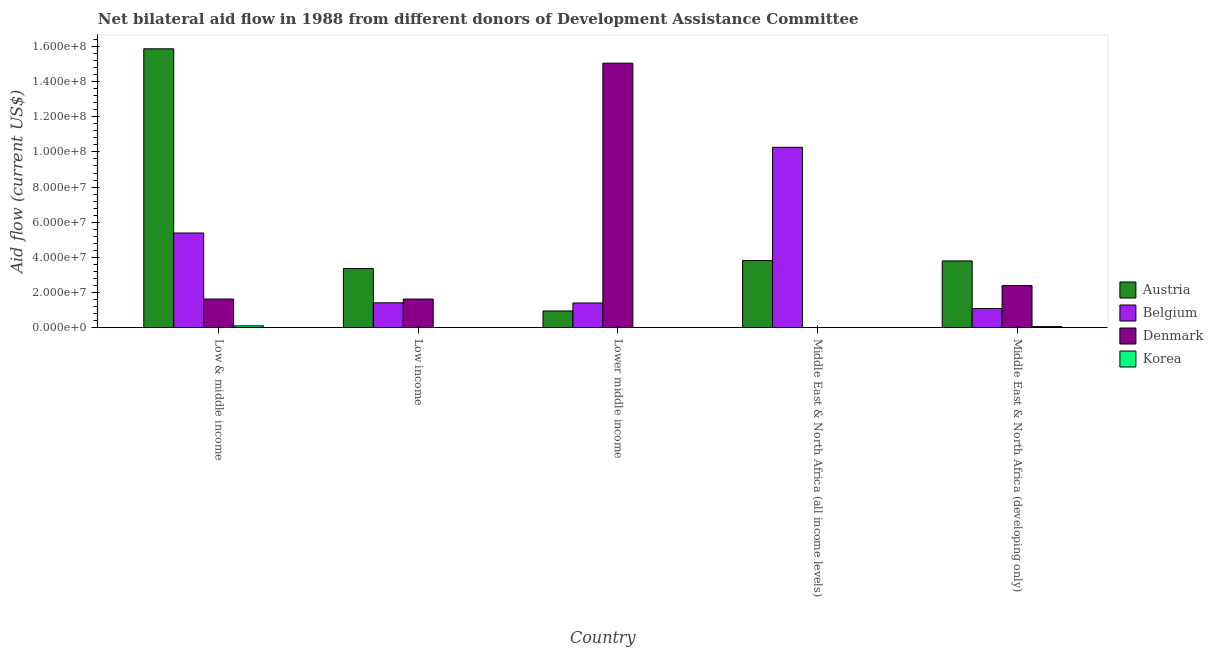Are the number of bars on each tick of the X-axis equal?
Provide a succinct answer. No. What is the label of the 2nd group of bars from the left?
Give a very brief answer. Low income. What is the amount of aid given by denmark in Low & middle income?
Ensure brevity in your answer.  1.63e+07. Across all countries, what is the maximum amount of aid given by korea?
Offer a very short reply. 1.03e+06. Across all countries, what is the minimum amount of aid given by austria?
Your answer should be very brief. 9.50e+06. In which country was the amount of aid given by korea maximum?
Ensure brevity in your answer.  Low & middle income. What is the total amount of aid given by austria in the graph?
Your answer should be compact. 2.78e+08. What is the difference between the amount of aid given by belgium in Low & middle income and that in Middle East & North Africa (all income levels)?
Make the answer very short. -4.88e+07. What is the difference between the amount of aid given by austria in Lower middle income and the amount of aid given by korea in Low & middle income?
Keep it short and to the point. 8.47e+06. What is the average amount of aid given by korea per country?
Make the answer very short. 3.48e+05. What is the difference between the amount of aid given by denmark and amount of aid given by austria in Low income?
Your answer should be compact. -1.74e+07. What is the ratio of the amount of aid given by denmark in Low income to that in Middle East & North Africa (developing only)?
Your answer should be compact. 0.68. What is the difference between the highest and the second highest amount of aid given by denmark?
Provide a short and direct response. 1.27e+08. What is the difference between the highest and the lowest amount of aid given by belgium?
Provide a succinct answer. 9.18e+07. Is the sum of the amount of aid given by korea in Middle East & North Africa (all income levels) and Middle East & North Africa (developing only) greater than the maximum amount of aid given by austria across all countries?
Keep it short and to the point. No. How many countries are there in the graph?
Your response must be concise. 5. Does the graph contain any zero values?
Your answer should be compact. Yes. Does the graph contain grids?
Your answer should be very brief. No. Where does the legend appear in the graph?
Keep it short and to the point. Center right. How many legend labels are there?
Give a very brief answer. 4. What is the title of the graph?
Your answer should be very brief. Net bilateral aid flow in 1988 from different donors of Development Assistance Committee. Does "Portugal" appear as one of the legend labels in the graph?
Keep it short and to the point. No. What is the label or title of the X-axis?
Your response must be concise. Country. What is the label or title of the Y-axis?
Provide a short and direct response. Aid flow (current US$). What is the Aid flow (current US$) of Austria in Low & middle income?
Provide a short and direct response. 1.59e+08. What is the Aid flow (current US$) of Belgium in Low & middle income?
Ensure brevity in your answer.  5.39e+07. What is the Aid flow (current US$) in Denmark in Low & middle income?
Provide a short and direct response. 1.63e+07. What is the Aid flow (current US$) of Korea in Low & middle income?
Make the answer very short. 1.03e+06. What is the Aid flow (current US$) of Austria in Low income?
Provide a short and direct response. 3.36e+07. What is the Aid flow (current US$) of Belgium in Low income?
Give a very brief answer. 1.41e+07. What is the Aid flow (current US$) in Denmark in Low income?
Offer a terse response. 1.63e+07. What is the Aid flow (current US$) in Korea in Low income?
Give a very brief answer. 3.00e+04. What is the Aid flow (current US$) in Austria in Lower middle income?
Ensure brevity in your answer.  9.50e+06. What is the Aid flow (current US$) of Belgium in Lower middle income?
Offer a very short reply. 1.40e+07. What is the Aid flow (current US$) in Denmark in Lower middle income?
Your answer should be very brief. 1.50e+08. What is the Aid flow (current US$) in Korea in Lower middle income?
Provide a succinct answer. 3.00e+04. What is the Aid flow (current US$) of Austria in Middle East & North Africa (all income levels)?
Keep it short and to the point. 3.82e+07. What is the Aid flow (current US$) of Belgium in Middle East & North Africa (all income levels)?
Give a very brief answer. 1.03e+08. What is the Aid flow (current US$) in Austria in Middle East & North Africa (developing only)?
Your answer should be very brief. 3.80e+07. What is the Aid flow (current US$) in Belgium in Middle East & North Africa (developing only)?
Keep it short and to the point. 1.09e+07. What is the Aid flow (current US$) in Denmark in Middle East & North Africa (developing only)?
Provide a short and direct response. 2.40e+07. What is the Aid flow (current US$) of Korea in Middle East & North Africa (developing only)?
Ensure brevity in your answer.  6.20e+05. Across all countries, what is the maximum Aid flow (current US$) in Austria?
Offer a terse response. 1.59e+08. Across all countries, what is the maximum Aid flow (current US$) of Belgium?
Your answer should be very brief. 1.03e+08. Across all countries, what is the maximum Aid flow (current US$) in Denmark?
Your response must be concise. 1.50e+08. Across all countries, what is the maximum Aid flow (current US$) in Korea?
Your answer should be compact. 1.03e+06. Across all countries, what is the minimum Aid flow (current US$) in Austria?
Provide a short and direct response. 9.50e+06. Across all countries, what is the minimum Aid flow (current US$) of Belgium?
Make the answer very short. 1.09e+07. Across all countries, what is the minimum Aid flow (current US$) of Denmark?
Provide a short and direct response. 0. What is the total Aid flow (current US$) of Austria in the graph?
Offer a terse response. 2.78e+08. What is the total Aid flow (current US$) in Belgium in the graph?
Ensure brevity in your answer.  1.96e+08. What is the total Aid flow (current US$) of Denmark in the graph?
Offer a very short reply. 2.07e+08. What is the total Aid flow (current US$) of Korea in the graph?
Ensure brevity in your answer.  1.74e+06. What is the difference between the Aid flow (current US$) of Austria in Low & middle income and that in Low income?
Offer a very short reply. 1.25e+08. What is the difference between the Aid flow (current US$) in Belgium in Low & middle income and that in Low income?
Your answer should be compact. 3.97e+07. What is the difference between the Aid flow (current US$) of Korea in Low & middle income and that in Low income?
Provide a short and direct response. 1.00e+06. What is the difference between the Aid flow (current US$) in Austria in Low & middle income and that in Lower middle income?
Your answer should be very brief. 1.49e+08. What is the difference between the Aid flow (current US$) of Belgium in Low & middle income and that in Lower middle income?
Provide a succinct answer. 3.98e+07. What is the difference between the Aid flow (current US$) in Denmark in Low & middle income and that in Lower middle income?
Make the answer very short. -1.34e+08. What is the difference between the Aid flow (current US$) in Korea in Low & middle income and that in Lower middle income?
Ensure brevity in your answer.  1.00e+06. What is the difference between the Aid flow (current US$) of Austria in Low & middle income and that in Middle East & North Africa (all income levels)?
Your response must be concise. 1.20e+08. What is the difference between the Aid flow (current US$) of Belgium in Low & middle income and that in Middle East & North Africa (all income levels)?
Keep it short and to the point. -4.88e+07. What is the difference between the Aid flow (current US$) in Korea in Low & middle income and that in Middle East & North Africa (all income levels)?
Offer a terse response. 1.00e+06. What is the difference between the Aid flow (current US$) of Austria in Low & middle income and that in Middle East & North Africa (developing only)?
Provide a succinct answer. 1.21e+08. What is the difference between the Aid flow (current US$) of Belgium in Low & middle income and that in Middle East & North Africa (developing only)?
Ensure brevity in your answer.  4.30e+07. What is the difference between the Aid flow (current US$) in Denmark in Low & middle income and that in Middle East & North Africa (developing only)?
Ensure brevity in your answer.  -7.68e+06. What is the difference between the Aid flow (current US$) in Korea in Low & middle income and that in Middle East & North Africa (developing only)?
Your answer should be compact. 4.10e+05. What is the difference between the Aid flow (current US$) of Austria in Low income and that in Lower middle income?
Offer a terse response. 2.41e+07. What is the difference between the Aid flow (current US$) of Denmark in Low income and that in Lower middle income?
Make the answer very short. -1.34e+08. What is the difference between the Aid flow (current US$) in Austria in Low income and that in Middle East & North Africa (all income levels)?
Offer a terse response. -4.56e+06. What is the difference between the Aid flow (current US$) of Belgium in Low income and that in Middle East & North Africa (all income levels)?
Your response must be concise. -8.85e+07. What is the difference between the Aid flow (current US$) of Korea in Low income and that in Middle East & North Africa (all income levels)?
Keep it short and to the point. 0. What is the difference between the Aid flow (current US$) of Austria in Low income and that in Middle East & North Africa (developing only)?
Provide a succinct answer. -4.34e+06. What is the difference between the Aid flow (current US$) in Belgium in Low income and that in Middle East & North Africa (developing only)?
Your answer should be very brief. 3.28e+06. What is the difference between the Aid flow (current US$) in Denmark in Low income and that in Middle East & North Africa (developing only)?
Your answer should be very brief. -7.70e+06. What is the difference between the Aid flow (current US$) of Korea in Low income and that in Middle East & North Africa (developing only)?
Your answer should be very brief. -5.90e+05. What is the difference between the Aid flow (current US$) of Austria in Lower middle income and that in Middle East & North Africa (all income levels)?
Make the answer very short. -2.87e+07. What is the difference between the Aid flow (current US$) of Belgium in Lower middle income and that in Middle East & North Africa (all income levels)?
Give a very brief answer. -8.86e+07. What is the difference between the Aid flow (current US$) in Austria in Lower middle income and that in Middle East & North Africa (developing only)?
Offer a terse response. -2.85e+07. What is the difference between the Aid flow (current US$) in Belgium in Lower middle income and that in Middle East & North Africa (developing only)?
Make the answer very short. 3.18e+06. What is the difference between the Aid flow (current US$) of Denmark in Lower middle income and that in Middle East & North Africa (developing only)?
Your response must be concise. 1.27e+08. What is the difference between the Aid flow (current US$) of Korea in Lower middle income and that in Middle East & North Africa (developing only)?
Ensure brevity in your answer.  -5.90e+05. What is the difference between the Aid flow (current US$) of Austria in Middle East & North Africa (all income levels) and that in Middle East & North Africa (developing only)?
Offer a terse response. 2.20e+05. What is the difference between the Aid flow (current US$) of Belgium in Middle East & North Africa (all income levels) and that in Middle East & North Africa (developing only)?
Keep it short and to the point. 9.18e+07. What is the difference between the Aid flow (current US$) of Korea in Middle East & North Africa (all income levels) and that in Middle East & North Africa (developing only)?
Your answer should be compact. -5.90e+05. What is the difference between the Aid flow (current US$) of Austria in Low & middle income and the Aid flow (current US$) of Belgium in Low income?
Your response must be concise. 1.45e+08. What is the difference between the Aid flow (current US$) in Austria in Low & middle income and the Aid flow (current US$) in Denmark in Low income?
Provide a short and direct response. 1.42e+08. What is the difference between the Aid flow (current US$) in Austria in Low & middle income and the Aid flow (current US$) in Korea in Low income?
Keep it short and to the point. 1.59e+08. What is the difference between the Aid flow (current US$) of Belgium in Low & middle income and the Aid flow (current US$) of Denmark in Low income?
Your answer should be compact. 3.76e+07. What is the difference between the Aid flow (current US$) of Belgium in Low & middle income and the Aid flow (current US$) of Korea in Low income?
Offer a terse response. 5.38e+07. What is the difference between the Aid flow (current US$) of Denmark in Low & middle income and the Aid flow (current US$) of Korea in Low income?
Keep it short and to the point. 1.63e+07. What is the difference between the Aid flow (current US$) in Austria in Low & middle income and the Aid flow (current US$) in Belgium in Lower middle income?
Offer a terse response. 1.45e+08. What is the difference between the Aid flow (current US$) of Austria in Low & middle income and the Aid flow (current US$) of Denmark in Lower middle income?
Offer a very short reply. 8.18e+06. What is the difference between the Aid flow (current US$) of Austria in Low & middle income and the Aid flow (current US$) of Korea in Lower middle income?
Provide a short and direct response. 1.59e+08. What is the difference between the Aid flow (current US$) in Belgium in Low & middle income and the Aid flow (current US$) in Denmark in Lower middle income?
Your answer should be compact. -9.66e+07. What is the difference between the Aid flow (current US$) in Belgium in Low & middle income and the Aid flow (current US$) in Korea in Lower middle income?
Your answer should be very brief. 5.38e+07. What is the difference between the Aid flow (current US$) in Denmark in Low & middle income and the Aid flow (current US$) in Korea in Lower middle income?
Give a very brief answer. 1.63e+07. What is the difference between the Aid flow (current US$) in Austria in Low & middle income and the Aid flow (current US$) in Belgium in Middle East & North Africa (all income levels)?
Ensure brevity in your answer.  5.60e+07. What is the difference between the Aid flow (current US$) in Austria in Low & middle income and the Aid flow (current US$) in Korea in Middle East & North Africa (all income levels)?
Provide a short and direct response. 1.59e+08. What is the difference between the Aid flow (current US$) in Belgium in Low & middle income and the Aid flow (current US$) in Korea in Middle East & North Africa (all income levels)?
Keep it short and to the point. 5.38e+07. What is the difference between the Aid flow (current US$) of Denmark in Low & middle income and the Aid flow (current US$) of Korea in Middle East & North Africa (all income levels)?
Your response must be concise. 1.63e+07. What is the difference between the Aid flow (current US$) in Austria in Low & middle income and the Aid flow (current US$) in Belgium in Middle East & North Africa (developing only)?
Your answer should be compact. 1.48e+08. What is the difference between the Aid flow (current US$) of Austria in Low & middle income and the Aid flow (current US$) of Denmark in Middle East & North Africa (developing only)?
Offer a very short reply. 1.35e+08. What is the difference between the Aid flow (current US$) in Austria in Low & middle income and the Aid flow (current US$) in Korea in Middle East & North Africa (developing only)?
Ensure brevity in your answer.  1.58e+08. What is the difference between the Aid flow (current US$) in Belgium in Low & middle income and the Aid flow (current US$) in Denmark in Middle East & North Africa (developing only)?
Your response must be concise. 2.99e+07. What is the difference between the Aid flow (current US$) of Belgium in Low & middle income and the Aid flow (current US$) of Korea in Middle East & North Africa (developing only)?
Keep it short and to the point. 5.32e+07. What is the difference between the Aid flow (current US$) of Denmark in Low & middle income and the Aid flow (current US$) of Korea in Middle East & North Africa (developing only)?
Make the answer very short. 1.57e+07. What is the difference between the Aid flow (current US$) in Austria in Low income and the Aid flow (current US$) in Belgium in Lower middle income?
Your response must be concise. 1.96e+07. What is the difference between the Aid flow (current US$) in Austria in Low income and the Aid flow (current US$) in Denmark in Lower middle income?
Offer a very short reply. -1.17e+08. What is the difference between the Aid flow (current US$) in Austria in Low income and the Aid flow (current US$) in Korea in Lower middle income?
Provide a succinct answer. 3.36e+07. What is the difference between the Aid flow (current US$) in Belgium in Low income and the Aid flow (current US$) in Denmark in Lower middle income?
Your response must be concise. -1.36e+08. What is the difference between the Aid flow (current US$) of Belgium in Low income and the Aid flow (current US$) of Korea in Lower middle income?
Offer a terse response. 1.41e+07. What is the difference between the Aid flow (current US$) in Denmark in Low income and the Aid flow (current US$) in Korea in Lower middle income?
Ensure brevity in your answer.  1.62e+07. What is the difference between the Aid flow (current US$) of Austria in Low income and the Aid flow (current US$) of Belgium in Middle East & North Africa (all income levels)?
Provide a succinct answer. -6.90e+07. What is the difference between the Aid flow (current US$) in Austria in Low income and the Aid flow (current US$) in Korea in Middle East & North Africa (all income levels)?
Your response must be concise. 3.36e+07. What is the difference between the Aid flow (current US$) in Belgium in Low income and the Aid flow (current US$) in Korea in Middle East & North Africa (all income levels)?
Provide a short and direct response. 1.41e+07. What is the difference between the Aid flow (current US$) in Denmark in Low income and the Aid flow (current US$) in Korea in Middle East & North Africa (all income levels)?
Your answer should be very brief. 1.62e+07. What is the difference between the Aid flow (current US$) in Austria in Low income and the Aid flow (current US$) in Belgium in Middle East & North Africa (developing only)?
Your answer should be very brief. 2.28e+07. What is the difference between the Aid flow (current US$) of Austria in Low income and the Aid flow (current US$) of Denmark in Middle East & North Africa (developing only)?
Provide a succinct answer. 9.66e+06. What is the difference between the Aid flow (current US$) of Austria in Low income and the Aid flow (current US$) of Korea in Middle East & North Africa (developing only)?
Provide a short and direct response. 3.30e+07. What is the difference between the Aid flow (current US$) of Belgium in Low income and the Aid flow (current US$) of Denmark in Middle East & North Africa (developing only)?
Your response must be concise. -9.83e+06. What is the difference between the Aid flow (current US$) of Belgium in Low income and the Aid flow (current US$) of Korea in Middle East & North Africa (developing only)?
Give a very brief answer. 1.35e+07. What is the difference between the Aid flow (current US$) in Denmark in Low income and the Aid flow (current US$) in Korea in Middle East & North Africa (developing only)?
Provide a succinct answer. 1.56e+07. What is the difference between the Aid flow (current US$) of Austria in Lower middle income and the Aid flow (current US$) of Belgium in Middle East & North Africa (all income levels)?
Your answer should be compact. -9.32e+07. What is the difference between the Aid flow (current US$) of Austria in Lower middle income and the Aid flow (current US$) of Korea in Middle East & North Africa (all income levels)?
Offer a terse response. 9.47e+06. What is the difference between the Aid flow (current US$) in Belgium in Lower middle income and the Aid flow (current US$) in Korea in Middle East & North Africa (all income levels)?
Your answer should be very brief. 1.40e+07. What is the difference between the Aid flow (current US$) in Denmark in Lower middle income and the Aid flow (current US$) in Korea in Middle East & North Africa (all income levels)?
Give a very brief answer. 1.50e+08. What is the difference between the Aid flow (current US$) of Austria in Lower middle income and the Aid flow (current US$) of Belgium in Middle East & North Africa (developing only)?
Provide a short and direct response. -1.36e+06. What is the difference between the Aid flow (current US$) in Austria in Lower middle income and the Aid flow (current US$) in Denmark in Middle East & North Africa (developing only)?
Make the answer very short. -1.45e+07. What is the difference between the Aid flow (current US$) of Austria in Lower middle income and the Aid flow (current US$) of Korea in Middle East & North Africa (developing only)?
Provide a succinct answer. 8.88e+06. What is the difference between the Aid flow (current US$) in Belgium in Lower middle income and the Aid flow (current US$) in Denmark in Middle East & North Africa (developing only)?
Your response must be concise. -9.93e+06. What is the difference between the Aid flow (current US$) in Belgium in Lower middle income and the Aid flow (current US$) in Korea in Middle East & North Africa (developing only)?
Offer a very short reply. 1.34e+07. What is the difference between the Aid flow (current US$) of Denmark in Lower middle income and the Aid flow (current US$) of Korea in Middle East & North Africa (developing only)?
Give a very brief answer. 1.50e+08. What is the difference between the Aid flow (current US$) in Austria in Middle East & North Africa (all income levels) and the Aid flow (current US$) in Belgium in Middle East & North Africa (developing only)?
Make the answer very short. 2.73e+07. What is the difference between the Aid flow (current US$) of Austria in Middle East & North Africa (all income levels) and the Aid flow (current US$) of Denmark in Middle East & North Africa (developing only)?
Make the answer very short. 1.42e+07. What is the difference between the Aid flow (current US$) of Austria in Middle East & North Africa (all income levels) and the Aid flow (current US$) of Korea in Middle East & North Africa (developing only)?
Your response must be concise. 3.76e+07. What is the difference between the Aid flow (current US$) in Belgium in Middle East & North Africa (all income levels) and the Aid flow (current US$) in Denmark in Middle East & North Africa (developing only)?
Offer a terse response. 7.87e+07. What is the difference between the Aid flow (current US$) of Belgium in Middle East & North Africa (all income levels) and the Aid flow (current US$) of Korea in Middle East & North Africa (developing only)?
Provide a short and direct response. 1.02e+08. What is the average Aid flow (current US$) in Austria per country?
Your answer should be compact. 5.56e+07. What is the average Aid flow (current US$) in Belgium per country?
Ensure brevity in your answer.  3.91e+07. What is the average Aid flow (current US$) in Denmark per country?
Keep it short and to the point. 4.14e+07. What is the average Aid flow (current US$) of Korea per country?
Your answer should be very brief. 3.48e+05. What is the difference between the Aid flow (current US$) of Austria and Aid flow (current US$) of Belgium in Low & middle income?
Make the answer very short. 1.05e+08. What is the difference between the Aid flow (current US$) of Austria and Aid flow (current US$) of Denmark in Low & middle income?
Offer a terse response. 1.42e+08. What is the difference between the Aid flow (current US$) in Austria and Aid flow (current US$) in Korea in Low & middle income?
Give a very brief answer. 1.58e+08. What is the difference between the Aid flow (current US$) of Belgium and Aid flow (current US$) of Denmark in Low & middle income?
Your response must be concise. 3.76e+07. What is the difference between the Aid flow (current US$) of Belgium and Aid flow (current US$) of Korea in Low & middle income?
Keep it short and to the point. 5.28e+07. What is the difference between the Aid flow (current US$) of Denmark and Aid flow (current US$) of Korea in Low & middle income?
Ensure brevity in your answer.  1.53e+07. What is the difference between the Aid flow (current US$) in Austria and Aid flow (current US$) in Belgium in Low income?
Offer a very short reply. 1.95e+07. What is the difference between the Aid flow (current US$) of Austria and Aid flow (current US$) of Denmark in Low income?
Your response must be concise. 1.74e+07. What is the difference between the Aid flow (current US$) in Austria and Aid flow (current US$) in Korea in Low income?
Offer a very short reply. 3.36e+07. What is the difference between the Aid flow (current US$) of Belgium and Aid flow (current US$) of Denmark in Low income?
Provide a succinct answer. -2.13e+06. What is the difference between the Aid flow (current US$) in Belgium and Aid flow (current US$) in Korea in Low income?
Your answer should be very brief. 1.41e+07. What is the difference between the Aid flow (current US$) in Denmark and Aid flow (current US$) in Korea in Low income?
Provide a succinct answer. 1.62e+07. What is the difference between the Aid flow (current US$) of Austria and Aid flow (current US$) of Belgium in Lower middle income?
Keep it short and to the point. -4.54e+06. What is the difference between the Aid flow (current US$) of Austria and Aid flow (current US$) of Denmark in Lower middle income?
Your answer should be compact. -1.41e+08. What is the difference between the Aid flow (current US$) in Austria and Aid flow (current US$) in Korea in Lower middle income?
Provide a short and direct response. 9.47e+06. What is the difference between the Aid flow (current US$) in Belgium and Aid flow (current US$) in Denmark in Lower middle income?
Give a very brief answer. -1.36e+08. What is the difference between the Aid flow (current US$) in Belgium and Aid flow (current US$) in Korea in Lower middle income?
Your answer should be compact. 1.40e+07. What is the difference between the Aid flow (current US$) of Denmark and Aid flow (current US$) of Korea in Lower middle income?
Keep it short and to the point. 1.50e+08. What is the difference between the Aid flow (current US$) of Austria and Aid flow (current US$) of Belgium in Middle East & North Africa (all income levels)?
Provide a succinct answer. -6.45e+07. What is the difference between the Aid flow (current US$) in Austria and Aid flow (current US$) in Korea in Middle East & North Africa (all income levels)?
Provide a succinct answer. 3.82e+07. What is the difference between the Aid flow (current US$) in Belgium and Aid flow (current US$) in Korea in Middle East & North Africa (all income levels)?
Your response must be concise. 1.03e+08. What is the difference between the Aid flow (current US$) in Austria and Aid flow (current US$) in Belgium in Middle East & North Africa (developing only)?
Your answer should be very brief. 2.71e+07. What is the difference between the Aid flow (current US$) in Austria and Aid flow (current US$) in Denmark in Middle East & North Africa (developing only)?
Make the answer very short. 1.40e+07. What is the difference between the Aid flow (current US$) of Austria and Aid flow (current US$) of Korea in Middle East & North Africa (developing only)?
Provide a short and direct response. 3.74e+07. What is the difference between the Aid flow (current US$) in Belgium and Aid flow (current US$) in Denmark in Middle East & North Africa (developing only)?
Keep it short and to the point. -1.31e+07. What is the difference between the Aid flow (current US$) of Belgium and Aid flow (current US$) of Korea in Middle East & North Africa (developing only)?
Your response must be concise. 1.02e+07. What is the difference between the Aid flow (current US$) of Denmark and Aid flow (current US$) of Korea in Middle East & North Africa (developing only)?
Your answer should be very brief. 2.34e+07. What is the ratio of the Aid flow (current US$) in Austria in Low & middle income to that in Low income?
Provide a short and direct response. 4.72. What is the ratio of the Aid flow (current US$) of Belgium in Low & middle income to that in Low income?
Offer a very short reply. 3.81. What is the ratio of the Aid flow (current US$) of Denmark in Low & middle income to that in Low income?
Your answer should be very brief. 1. What is the ratio of the Aid flow (current US$) of Korea in Low & middle income to that in Low income?
Ensure brevity in your answer.  34.33. What is the ratio of the Aid flow (current US$) of Austria in Low & middle income to that in Lower middle income?
Keep it short and to the point. 16.7. What is the ratio of the Aid flow (current US$) in Belgium in Low & middle income to that in Lower middle income?
Ensure brevity in your answer.  3.84. What is the ratio of the Aid flow (current US$) in Denmark in Low & middle income to that in Lower middle income?
Your answer should be very brief. 0.11. What is the ratio of the Aid flow (current US$) in Korea in Low & middle income to that in Lower middle income?
Offer a terse response. 34.33. What is the ratio of the Aid flow (current US$) in Austria in Low & middle income to that in Middle East & North Africa (all income levels)?
Your answer should be compact. 4.15. What is the ratio of the Aid flow (current US$) in Belgium in Low & middle income to that in Middle East & North Africa (all income levels)?
Offer a very short reply. 0.52. What is the ratio of the Aid flow (current US$) of Korea in Low & middle income to that in Middle East & North Africa (all income levels)?
Offer a very short reply. 34.33. What is the ratio of the Aid flow (current US$) in Austria in Low & middle income to that in Middle East & North Africa (developing only)?
Offer a very short reply. 4.18. What is the ratio of the Aid flow (current US$) of Belgium in Low & middle income to that in Middle East & North Africa (developing only)?
Offer a very short reply. 4.96. What is the ratio of the Aid flow (current US$) of Denmark in Low & middle income to that in Middle East & North Africa (developing only)?
Your answer should be compact. 0.68. What is the ratio of the Aid flow (current US$) of Korea in Low & middle income to that in Middle East & North Africa (developing only)?
Your answer should be very brief. 1.66. What is the ratio of the Aid flow (current US$) in Austria in Low income to that in Lower middle income?
Your answer should be compact. 3.54. What is the ratio of the Aid flow (current US$) of Belgium in Low income to that in Lower middle income?
Offer a very short reply. 1.01. What is the ratio of the Aid flow (current US$) of Denmark in Low income to that in Lower middle income?
Ensure brevity in your answer.  0.11. What is the ratio of the Aid flow (current US$) in Austria in Low income to that in Middle East & North Africa (all income levels)?
Provide a short and direct response. 0.88. What is the ratio of the Aid flow (current US$) in Belgium in Low income to that in Middle East & North Africa (all income levels)?
Provide a succinct answer. 0.14. What is the ratio of the Aid flow (current US$) of Korea in Low income to that in Middle East & North Africa (all income levels)?
Ensure brevity in your answer.  1. What is the ratio of the Aid flow (current US$) of Austria in Low income to that in Middle East & North Africa (developing only)?
Keep it short and to the point. 0.89. What is the ratio of the Aid flow (current US$) in Belgium in Low income to that in Middle East & North Africa (developing only)?
Your answer should be compact. 1.3. What is the ratio of the Aid flow (current US$) of Denmark in Low income to that in Middle East & North Africa (developing only)?
Your response must be concise. 0.68. What is the ratio of the Aid flow (current US$) in Korea in Low income to that in Middle East & North Africa (developing only)?
Ensure brevity in your answer.  0.05. What is the ratio of the Aid flow (current US$) in Austria in Lower middle income to that in Middle East & North Africa (all income levels)?
Ensure brevity in your answer.  0.25. What is the ratio of the Aid flow (current US$) of Belgium in Lower middle income to that in Middle East & North Africa (all income levels)?
Give a very brief answer. 0.14. What is the ratio of the Aid flow (current US$) in Austria in Lower middle income to that in Middle East & North Africa (developing only)?
Provide a short and direct response. 0.25. What is the ratio of the Aid flow (current US$) in Belgium in Lower middle income to that in Middle East & North Africa (developing only)?
Ensure brevity in your answer.  1.29. What is the ratio of the Aid flow (current US$) of Denmark in Lower middle income to that in Middle East & North Africa (developing only)?
Ensure brevity in your answer.  6.28. What is the ratio of the Aid flow (current US$) in Korea in Lower middle income to that in Middle East & North Africa (developing only)?
Your response must be concise. 0.05. What is the ratio of the Aid flow (current US$) in Belgium in Middle East & North Africa (all income levels) to that in Middle East & North Africa (developing only)?
Offer a terse response. 9.45. What is the ratio of the Aid flow (current US$) of Korea in Middle East & North Africa (all income levels) to that in Middle East & North Africa (developing only)?
Ensure brevity in your answer.  0.05. What is the difference between the highest and the second highest Aid flow (current US$) in Austria?
Offer a very short reply. 1.20e+08. What is the difference between the highest and the second highest Aid flow (current US$) of Belgium?
Provide a succinct answer. 4.88e+07. What is the difference between the highest and the second highest Aid flow (current US$) of Denmark?
Provide a short and direct response. 1.27e+08. What is the difference between the highest and the second highest Aid flow (current US$) of Korea?
Your answer should be compact. 4.10e+05. What is the difference between the highest and the lowest Aid flow (current US$) of Austria?
Keep it short and to the point. 1.49e+08. What is the difference between the highest and the lowest Aid flow (current US$) in Belgium?
Your answer should be very brief. 9.18e+07. What is the difference between the highest and the lowest Aid flow (current US$) in Denmark?
Give a very brief answer. 1.50e+08. 